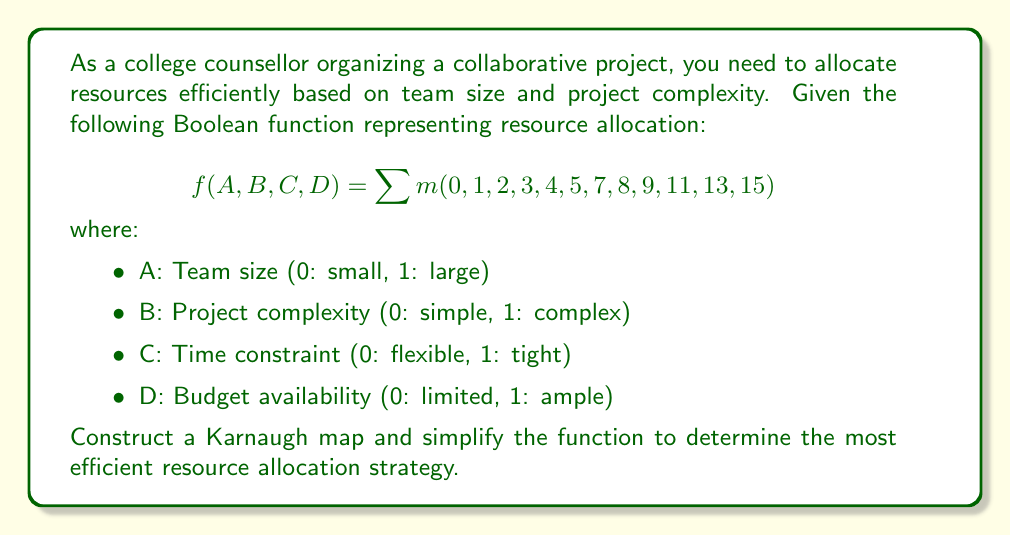Help me with this question. Step 1: Create a 4-variable Karnaugh map using A and B for columns, C and D for rows.

[asy]
unitsize(1cm);
draw((0,0)--(4,0)--(4,4)--(0,4)--cycle);
draw((0,1)--(4,1));
draw((0,2)--(4,2));
draw((0,3)--(4,3));
draw((1,0)--(1,4));
draw((2,0)--(2,4));
draw((3,0)--(3,4));
label("00", (0.5,3.5));
label("01", (1.5,3.5));
label("11", (2.5,3.5));
label("10", (3.5,3.5));
label("00", (-0.5,3.5));
label("01", (-0.5,2.5));
label("11", (-0.5,1.5));
label("10", (-0.5,0.5));
label("CD\AB", (-0.5,4.5));
label("1", (0.5,3.5));
label("1", (1.5,3.5));
label("1", (0.5,2.5));
label("1", (1.5,2.5));
label("1", (0.5,1.5));
label("1", (3.5,3.5));
label("1", (0.5,0.5));
label("1", (1.5,0.5));
label("1", (2.5,0.5));
label("1", (3.5,1.5));
label("1", (2.5,3.5));
label("1", (3.5,0.5));
[/asy]

Step 2: Identify the largest groups of 1s in the Karnaugh map.
- Group 1: $\overline{A}\overline{B}$ (4 cells)
- Group 2: $\overline{C}D$ (4 cells)
- Group 3: $A\overline{C}\overline{D}$ (2 cells)

Step 3: Write the simplified Boolean expression using the identified groups.
$f(A,B,C,D) = \overline{A}\overline{B} + \overline{C}D + A\overline{C}\overline{D}$

Step 4: Interpret the result:
- $\overline{A}\overline{B}$: Allocate resources for small teams with simple projects.
- $\overline{C}D$: Allocate resources when time is flexible and budget is ample.
- $A\overline{C}\overline{D}$: Allocate resources for large teams with flexible time and limited budget.
Answer: $f(A,B,C,D) = \overline{A}\overline{B} + \overline{C}D + A\overline{C}\overline{D}$ 